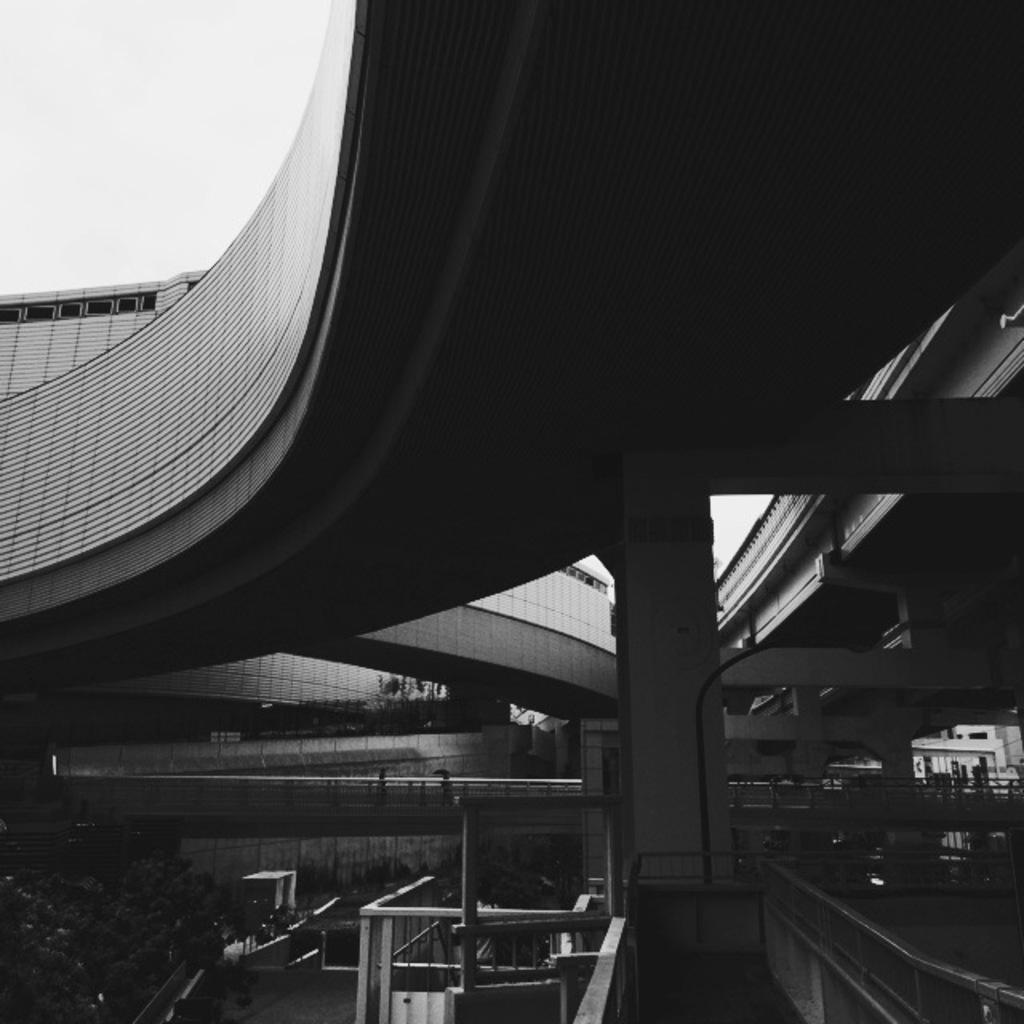What type of structures can be seen in the image? There are buildings in the image. Are there any architectural features visible in the image? Yes, there are staircases in the image. What type of natural elements are present in the image? There are trees in the image. Can you describe the people in the image? There are people in the image. What other objects can be seen in the image besides buildings, staircases, trees, and people? There are other objects in the image. How would you describe the weather in the image? The sky is cloudy in the image. What type of frame is visible in the image? There is no frame present in the image. Can you describe the iron content of the trees in the image? There is no information about the iron content of the trees in the image, and trees do not have iron content. 